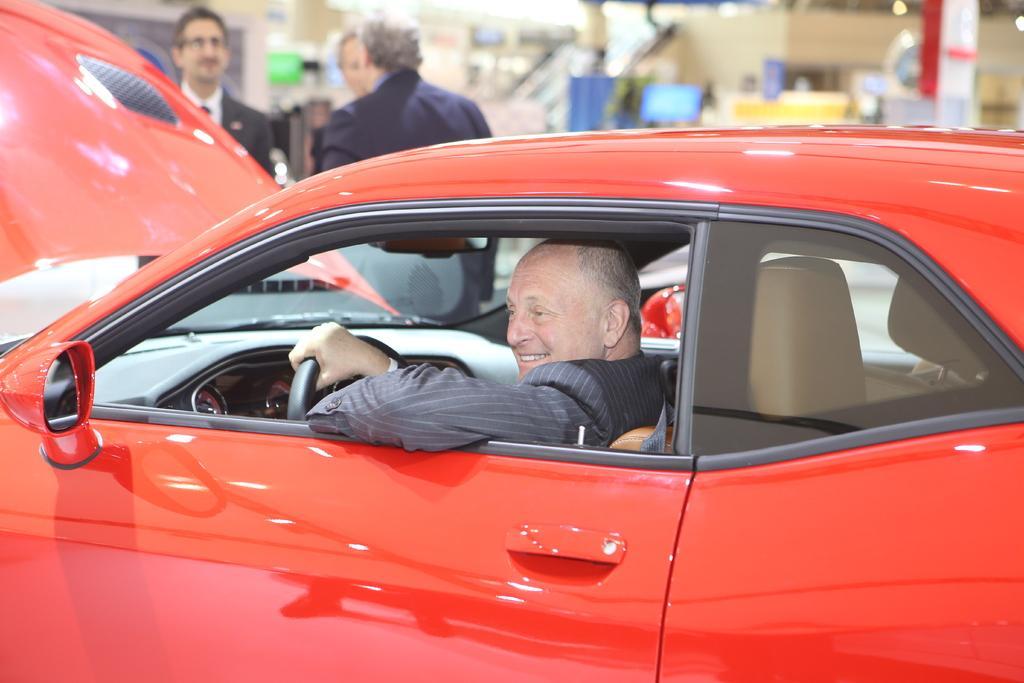Could you give a brief overview of what you see in this image? This is the picture of a red car, in the car a man is siting on a seat and holding steering. Behind the car there are persons standing on the floor and background is in blue. 